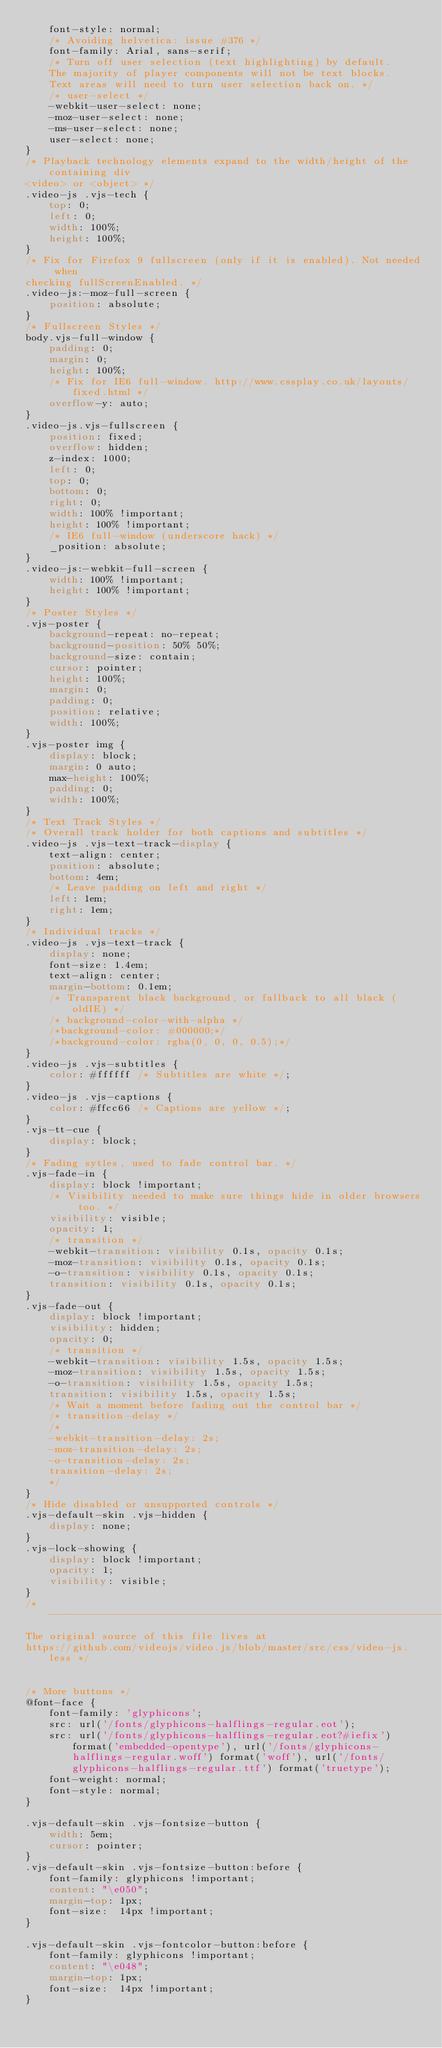Convert code to text. <code><loc_0><loc_0><loc_500><loc_500><_CSS_>    font-style: normal;
    /* Avoiding helvetica: issue #376 */
    font-family: Arial, sans-serif;
    /* Turn off user selection (text highlighting) by default.
    The majority of player components will not be text blocks.
    Text areas will need to turn user selection back on. */
    /* user-select */
    -webkit-user-select: none;
    -moz-user-select: none;
    -ms-user-select: none;
    user-select: none;
}
/* Playback technology elements expand to the width/height of the containing div
<video> or <object> */
.video-js .vjs-tech {
    top: 0;
    left: 0;
    width: 100%;
    height: 100%;
}
/* Fix for Firefox 9 fullscreen (only if it is enabled). Not needed when
checking fullScreenEnabled. */
.video-js:-moz-full-screen {
    position: absolute;
}
/* Fullscreen Styles */
body.vjs-full-window {
    padding: 0;
    margin: 0;
    height: 100%;
    /* Fix for IE6 full-window. http://www.cssplay.co.uk/layouts/fixed.html */
    overflow-y: auto;
}
.video-js.vjs-fullscreen {
    position: fixed;
    overflow: hidden;
    z-index: 1000;
    left: 0;
    top: 0;
    bottom: 0;
    right: 0;
    width: 100% !important;
    height: 100% !important;
    /* IE6 full-window (underscore hack) */
    _position: absolute;
}
.video-js:-webkit-full-screen {
    width: 100% !important;
    height: 100% !important;
}
/* Poster Styles */
.vjs-poster {
    background-repeat: no-repeat;
    background-position: 50% 50%;
    background-size: contain;
    cursor: pointer;
    height: 100%;
    margin: 0;
    padding: 0;
    position: relative;
    width: 100%;
}
.vjs-poster img {
    display: block;
    margin: 0 auto;
    max-height: 100%;
    padding: 0;
    width: 100%;
}
/* Text Track Styles */
/* Overall track holder for both captions and subtitles */
.video-js .vjs-text-track-display {
    text-align: center;
    position: absolute;
    bottom: 4em;
    /* Leave padding on left and right */
    left: 1em;
    right: 1em;
}
/* Individual tracks */
.video-js .vjs-text-track {
    display: none;
    font-size: 1.4em;
    text-align: center;
    margin-bottom: 0.1em;
    /* Transparent black background, or fallback to all black (oldIE) */
    /* background-color-with-alpha */
    /*background-color: #000000;*/
    /*background-color: rgba(0, 0, 0, 0.5);*/
}
.video-js .vjs-subtitles {
    color: #ffffff /* Subtitles are white */;
}
.video-js .vjs-captions {
    color: #ffcc66 /* Captions are yellow */;
}
.vjs-tt-cue {
    display: block;
}
/* Fading sytles, used to fade control bar. */
.vjs-fade-in {
    display: block !important;
    /* Visibility needed to make sure things hide in older browsers too. */
    visibility: visible;
    opacity: 1;
    /* transition */
    -webkit-transition: visibility 0.1s, opacity 0.1s;
    -moz-transition: visibility 0.1s, opacity 0.1s;
    -o-transition: visibility 0.1s, opacity 0.1s;
    transition: visibility 0.1s, opacity 0.1s;
}
.vjs-fade-out {
    display: block !important;
    visibility: hidden;
    opacity: 0;
    /* transition */
    -webkit-transition: visibility 1.5s, opacity 1.5s;
    -moz-transition: visibility 1.5s, opacity 1.5s;
    -o-transition: visibility 1.5s, opacity 1.5s;
    transition: visibility 1.5s, opacity 1.5s;
    /* Wait a moment before fading out the control bar */
    /* transition-delay */
    /*
    -webkit-transition-delay: 2s;
    -moz-transition-delay: 2s;
    -o-transition-delay: 2s;
    transition-delay: 2s;
    */
}
/* Hide disabled or unsupported controls */
.vjs-default-skin .vjs-hidden {
    display: none;
}
.vjs-lock-showing {
    display: block !important;
    opacity: 1;
    visibility: visible;
}
/* -----------------------------------------------------------------------------
The original source of this file lives at
https://github.com/videojs/video.js/blob/master/src/css/video-js.less */


/* More buttons */
@font-face {
    font-family: 'glyphicons';
    src: url('/fonts/glyphicons-halflings-regular.eot');
    src: url('/fonts/glyphicons-halflings-regular.eot?#iefix') format('embedded-opentype'), url('/fonts/glyphicons-halflings-regular.woff') format('woff'), url('/fonts/glyphicons-halflings-regular.ttf') format('truetype');
    font-weight: normal;
    font-style: normal;
}

.vjs-default-skin .vjs-fontsize-button {
    width: 5em;
    cursor: pointer;
}
.vjs-default-skin .vjs-fontsize-button:before {
    font-family: glyphicons !important;
    content: "\e050";
    margin-top: 1px;
    font-size:  14px !important;
}

.vjs-default-skin .vjs-fontcolor-button:before {
    font-family: glyphicons !important;
    content: "\e048";
    margin-top: 1px;
    font-size:  14px !important;
}
</code> 